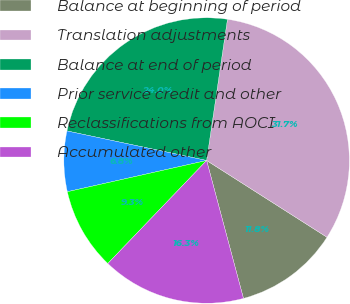Convert chart. <chart><loc_0><loc_0><loc_500><loc_500><pie_chart><fcel>Balance at beginning of period<fcel>Translation adjustments<fcel>Balance at end of period<fcel>Prior service credit and other<fcel>Reclassifications from AOCI<fcel>Accumulated other<nl><fcel>11.81%<fcel>31.7%<fcel>24.01%<fcel>6.83%<fcel>9.32%<fcel>16.32%<nl></chart> 